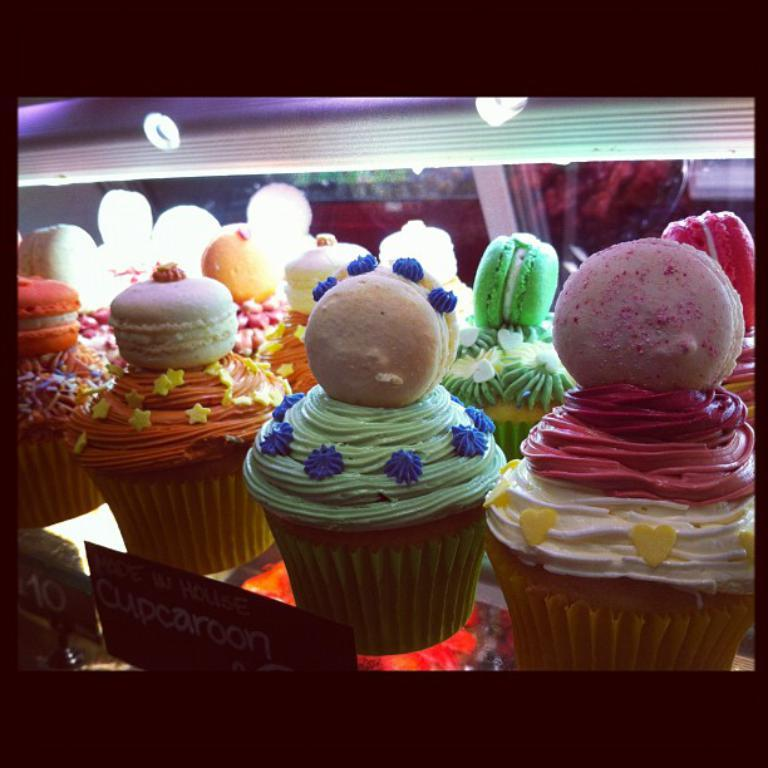What type of food is visible in the image? There are cupcakes in the image. How are the cupcakes arranged in the image? The cupcakes are placed in a rack. What feature is present in the rack? There are lights in the rack. What colors can be seen on the cupcakes? The cupcakes have various colors: light green, pink, green, and orange. What type of instrument is the carpenter playing in the image? There is no carpenter or instrument present in the image; it features cupcakes in a rack with lights. What color is the horn on the cupcakes? There is no horn present on the cupcakes; they are simply decorated with various colors. 